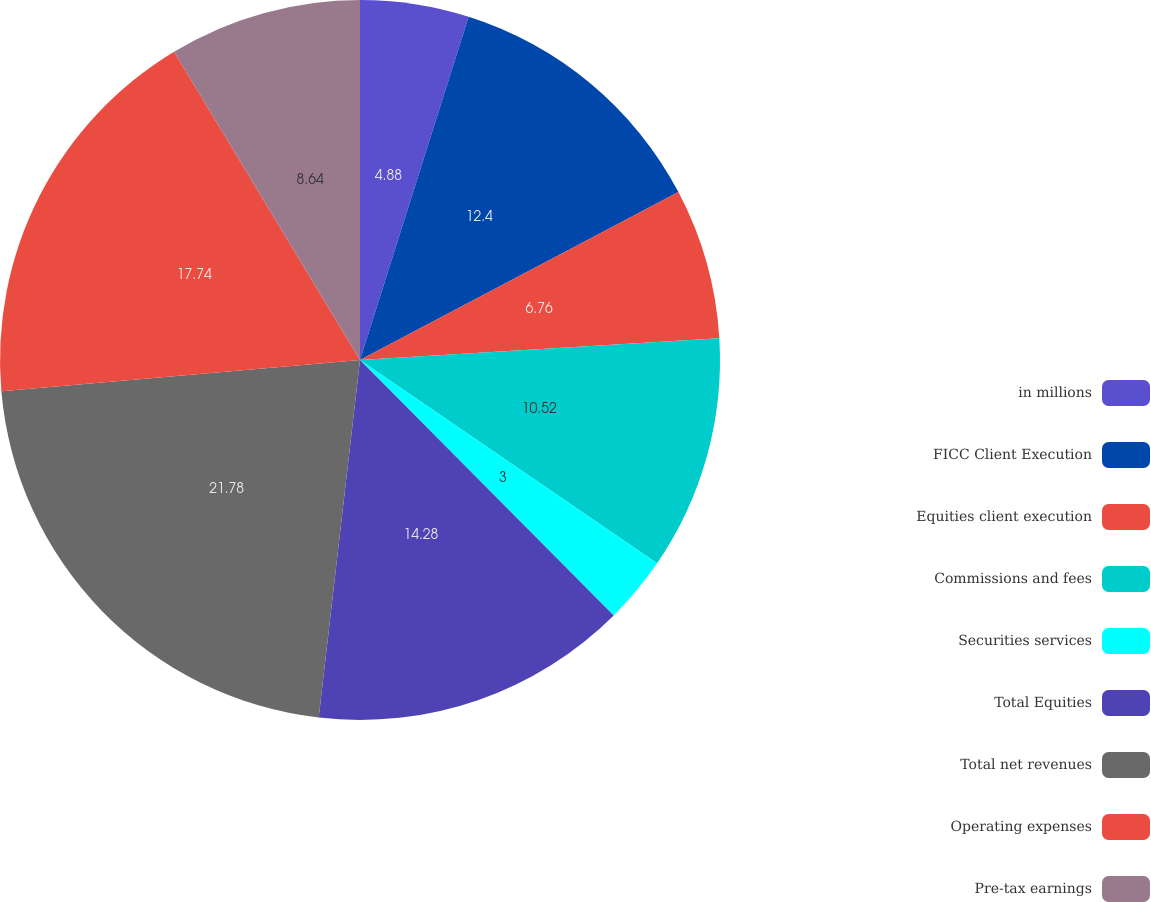Convert chart. <chart><loc_0><loc_0><loc_500><loc_500><pie_chart><fcel>in millions<fcel>FICC Client Execution<fcel>Equities client execution<fcel>Commissions and fees<fcel>Securities services<fcel>Total Equities<fcel>Total net revenues<fcel>Operating expenses<fcel>Pre-tax earnings<nl><fcel>4.88%<fcel>12.4%<fcel>6.76%<fcel>10.52%<fcel>3.0%<fcel>14.28%<fcel>21.79%<fcel>17.75%<fcel>8.64%<nl></chart> 